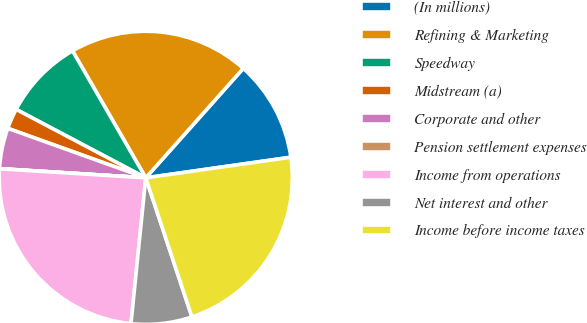<chart> <loc_0><loc_0><loc_500><loc_500><pie_chart><fcel>(In millions)<fcel>Refining & Marketing<fcel>Speedway<fcel>Midstream (a)<fcel>Corporate and other<fcel>Pension settlement expenses<fcel>Income from operations<fcel>Net interest and other<fcel>Income before income taxes<nl><fcel>11.17%<fcel>19.91%<fcel>8.94%<fcel>2.25%<fcel>4.48%<fcel>0.02%<fcel>24.37%<fcel>6.71%<fcel>22.14%<nl></chart> 